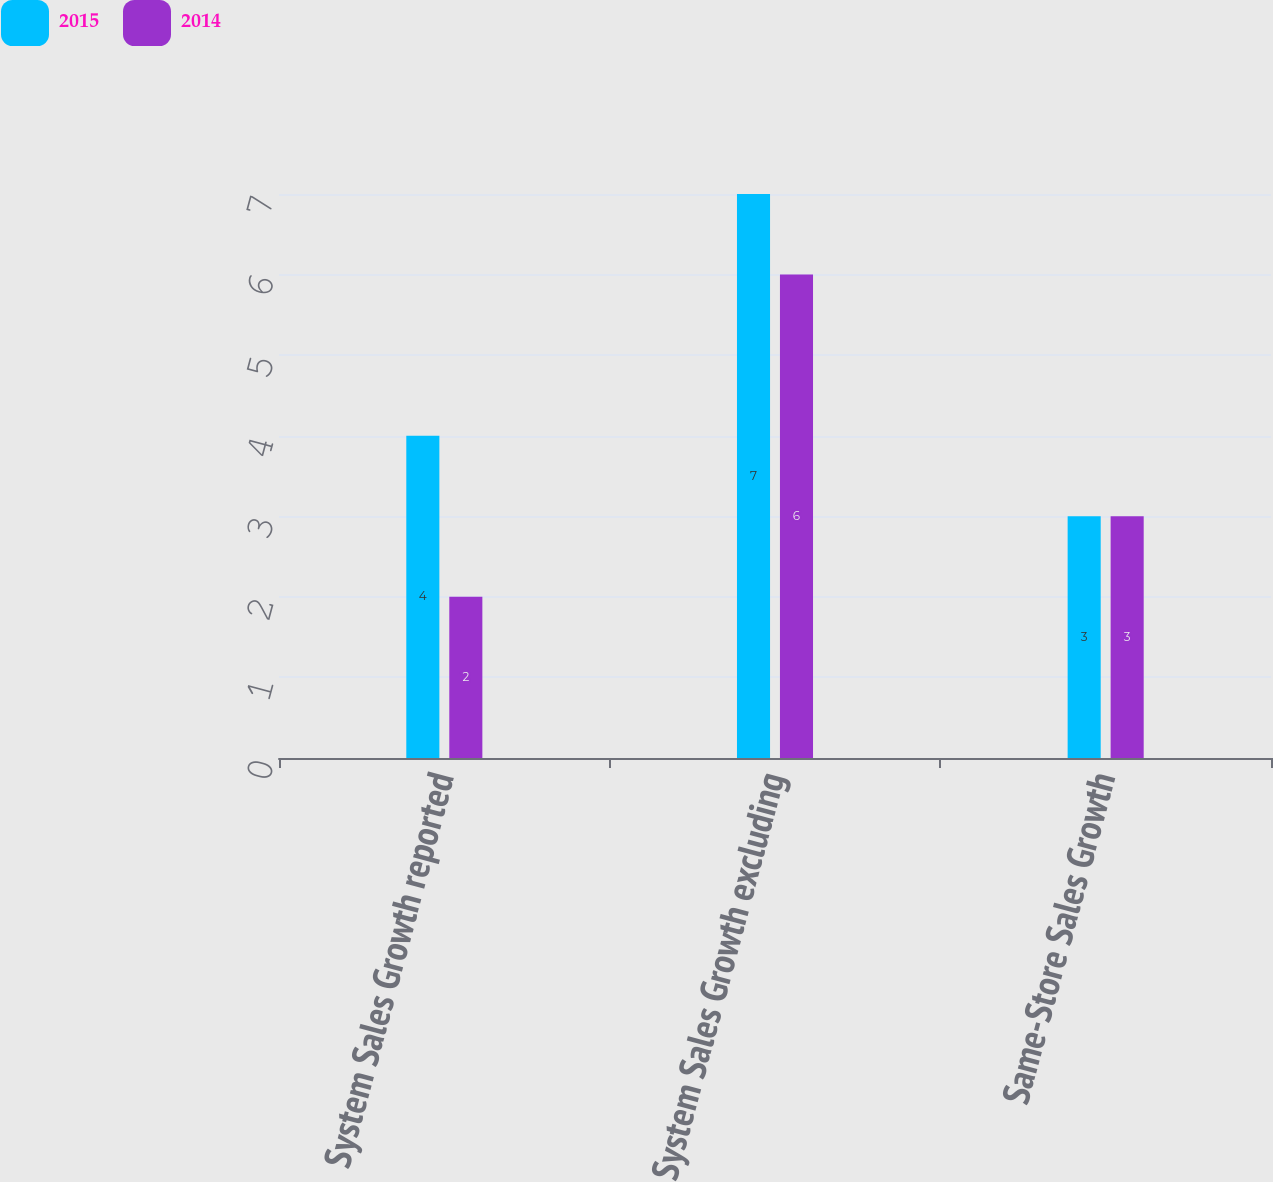<chart> <loc_0><loc_0><loc_500><loc_500><stacked_bar_chart><ecel><fcel>System Sales Growth reported<fcel>System Sales Growth excluding<fcel>Same-Store Sales Growth<nl><fcel>2015<fcel>4<fcel>7<fcel>3<nl><fcel>2014<fcel>2<fcel>6<fcel>3<nl></chart> 